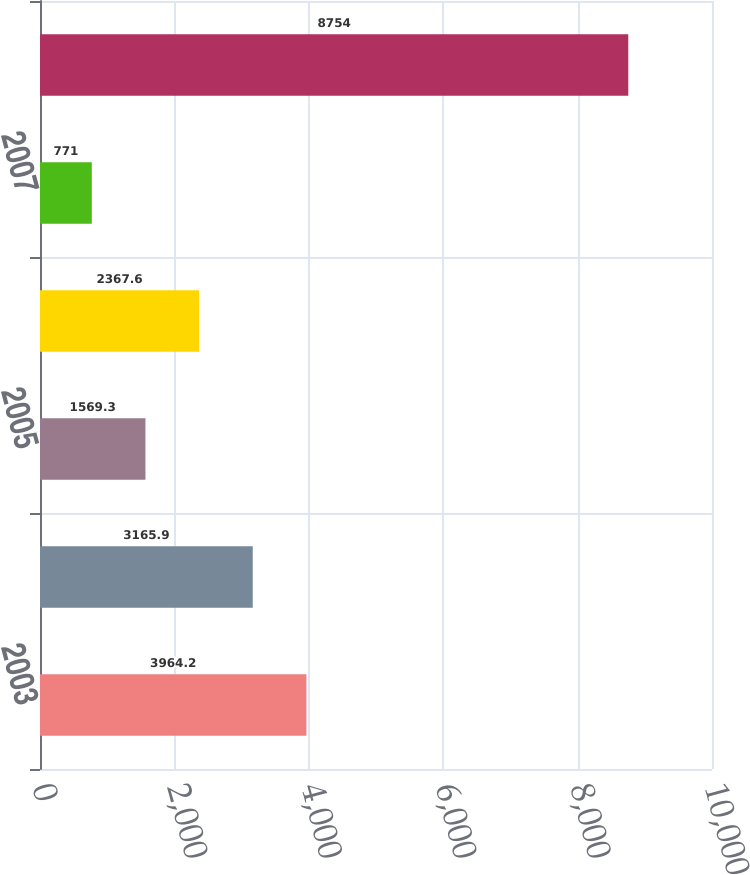<chart> <loc_0><loc_0><loc_500><loc_500><bar_chart><fcel>2003<fcel>2004<fcel>2005<fcel>2006<fcel>2007<fcel>Total future minimum lease<nl><fcel>3964.2<fcel>3165.9<fcel>1569.3<fcel>2367.6<fcel>771<fcel>8754<nl></chart> 